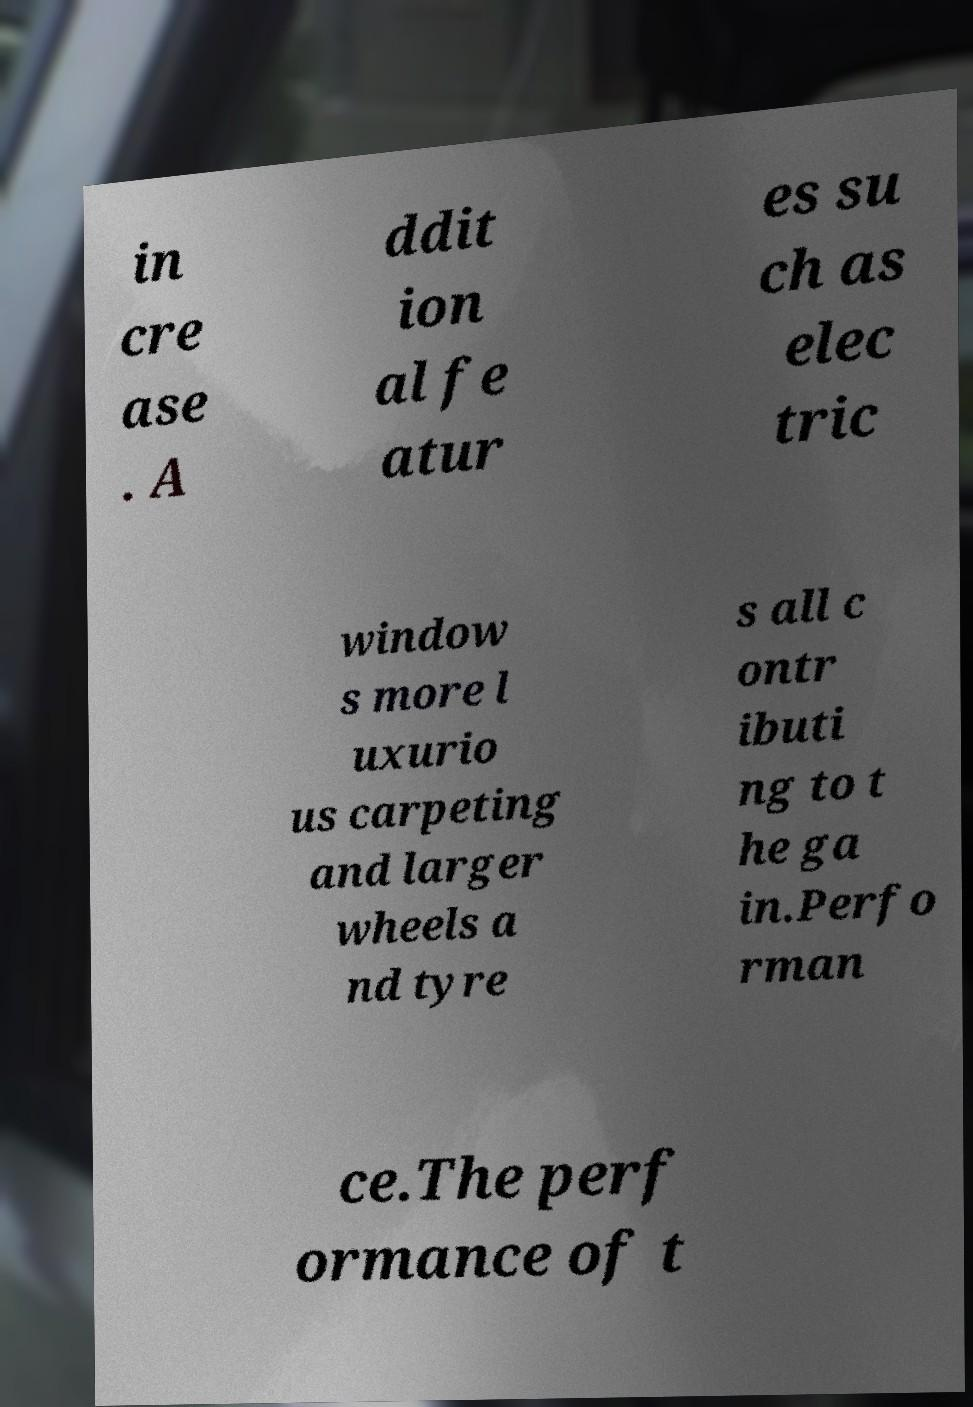There's text embedded in this image that I need extracted. Can you transcribe it verbatim? in cre ase . A ddit ion al fe atur es su ch as elec tric window s more l uxurio us carpeting and larger wheels a nd tyre s all c ontr ibuti ng to t he ga in.Perfo rman ce.The perf ormance of t 